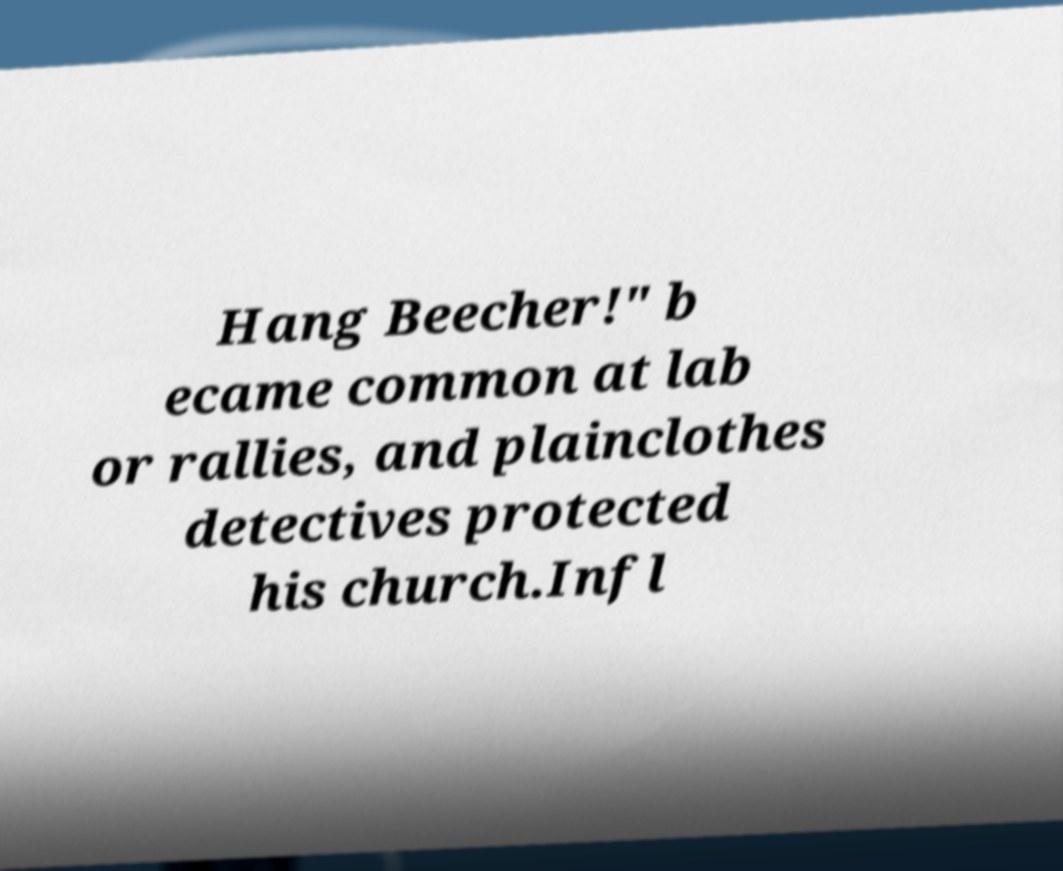What messages or text are displayed in this image? I need them in a readable, typed format. Hang Beecher!" b ecame common at lab or rallies, and plainclothes detectives protected his church.Infl 